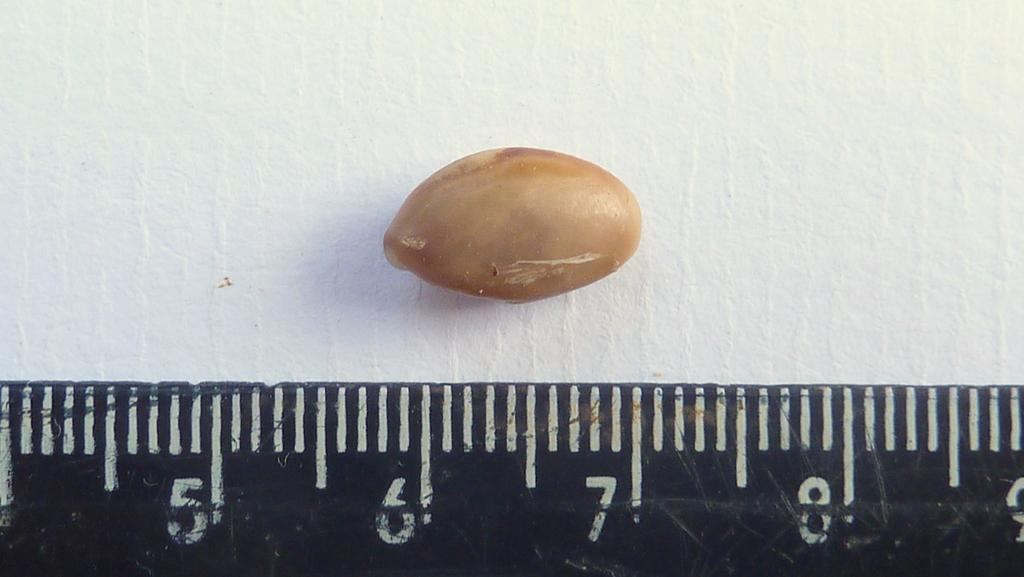Provide a one-sentence caption for the provided image. A peanut sits above the ruler measuring from 6 to 7. 